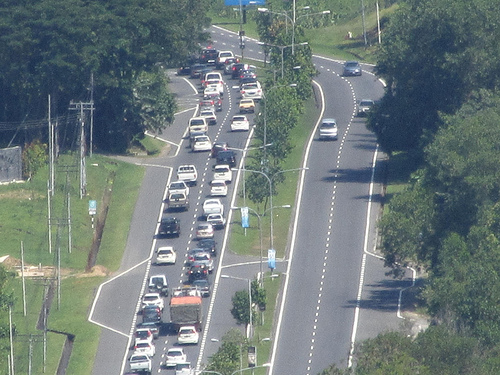<image>
Can you confirm if the tree is on the car? No. The tree is not positioned on the car. They may be near each other, but the tree is not supported by or resting on top of the car. 